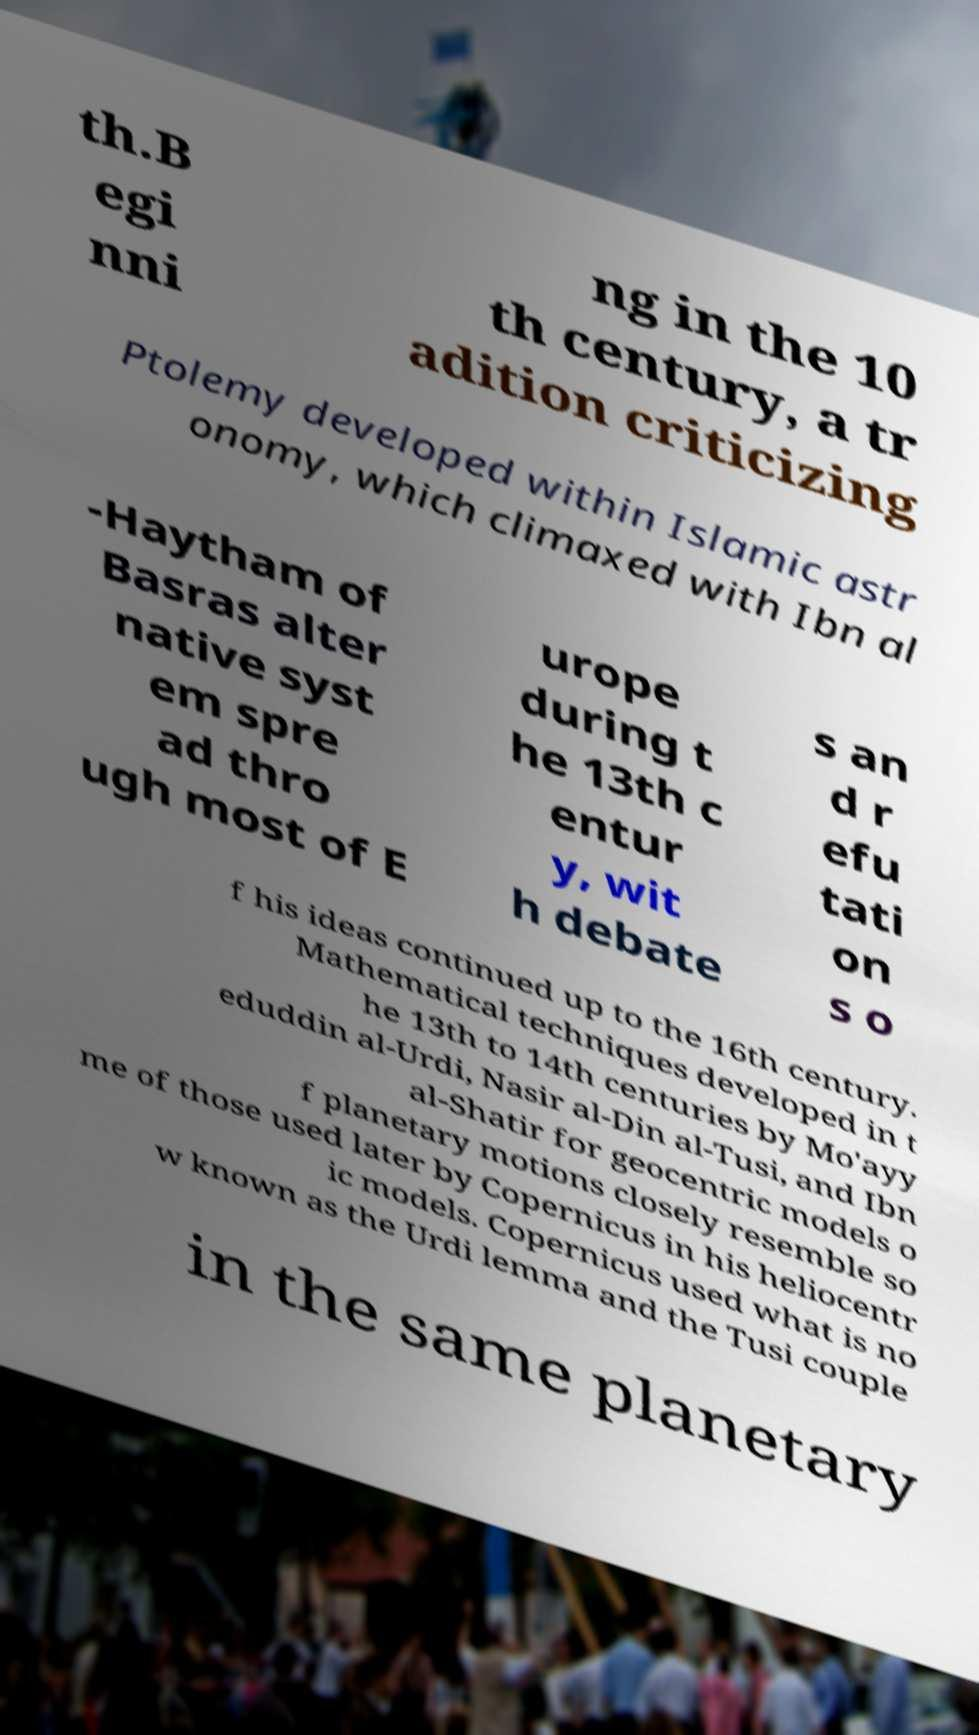I need the written content from this picture converted into text. Can you do that? th.B egi nni ng in the 10 th century, a tr adition criticizing Ptolemy developed within Islamic astr onomy, which climaxed with Ibn al -Haytham of Basras alter native syst em spre ad thro ugh most of E urope during t he 13th c entur y, wit h debate s an d r efu tati on s o f his ideas continued up to the 16th century. Mathematical techniques developed in t he 13th to 14th centuries by Mo'ayy eduddin al-Urdi, Nasir al-Din al-Tusi, and Ibn al-Shatir for geocentric models o f planetary motions closely resemble so me of those used later by Copernicus in his heliocentr ic models. Copernicus used what is no w known as the Urdi lemma and the Tusi couple in the same planetary 